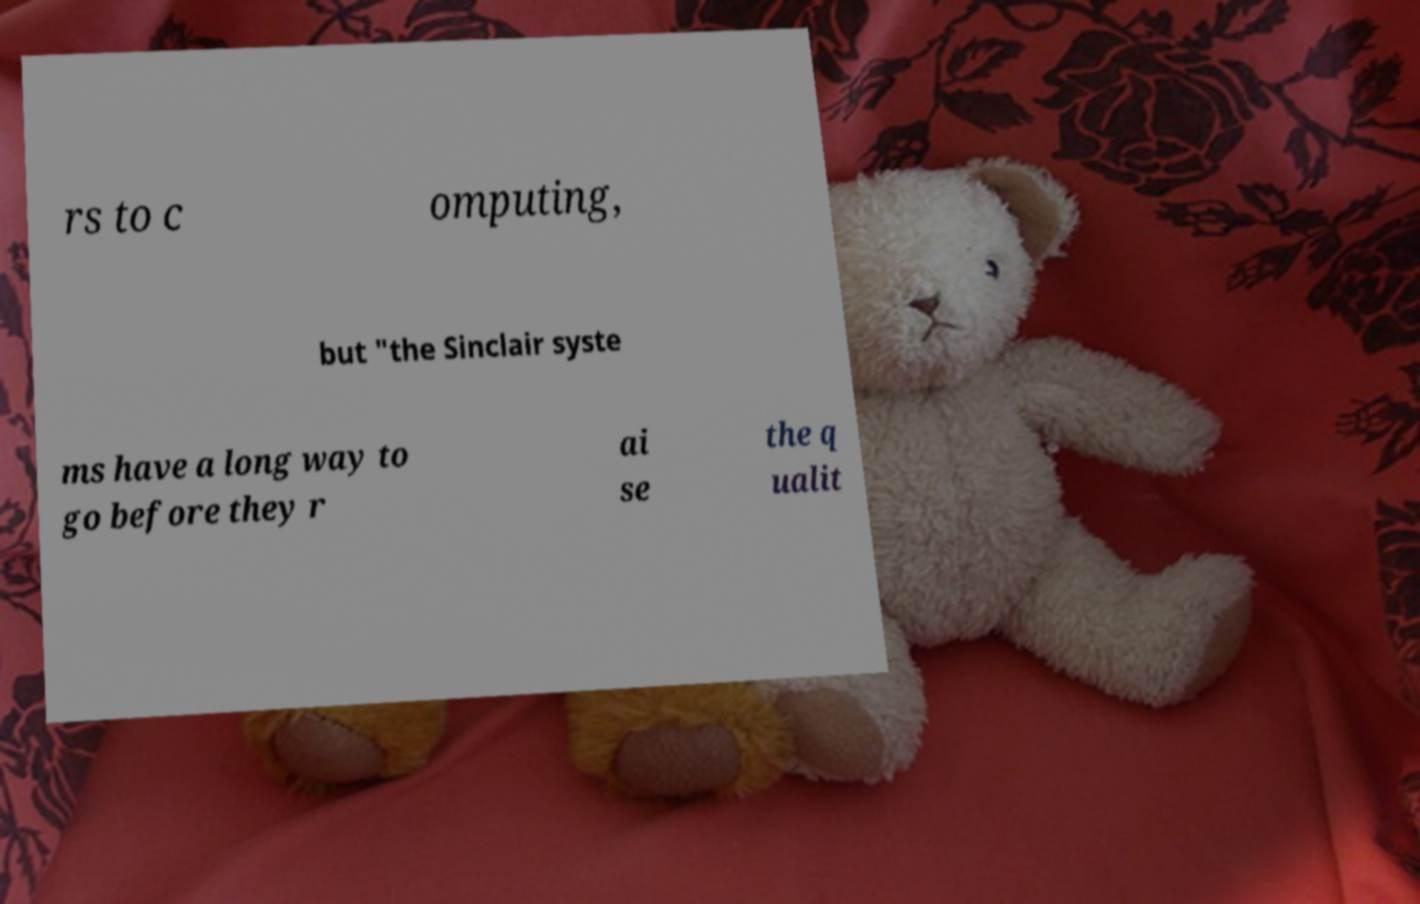Can you accurately transcribe the text from the provided image for me? rs to c omputing, but "the Sinclair syste ms have a long way to go before they r ai se the q ualit 